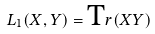<formula> <loc_0><loc_0><loc_500><loc_500>L _ { 1 } ( X , Y ) = { \mbox T r } ( X Y )</formula> 